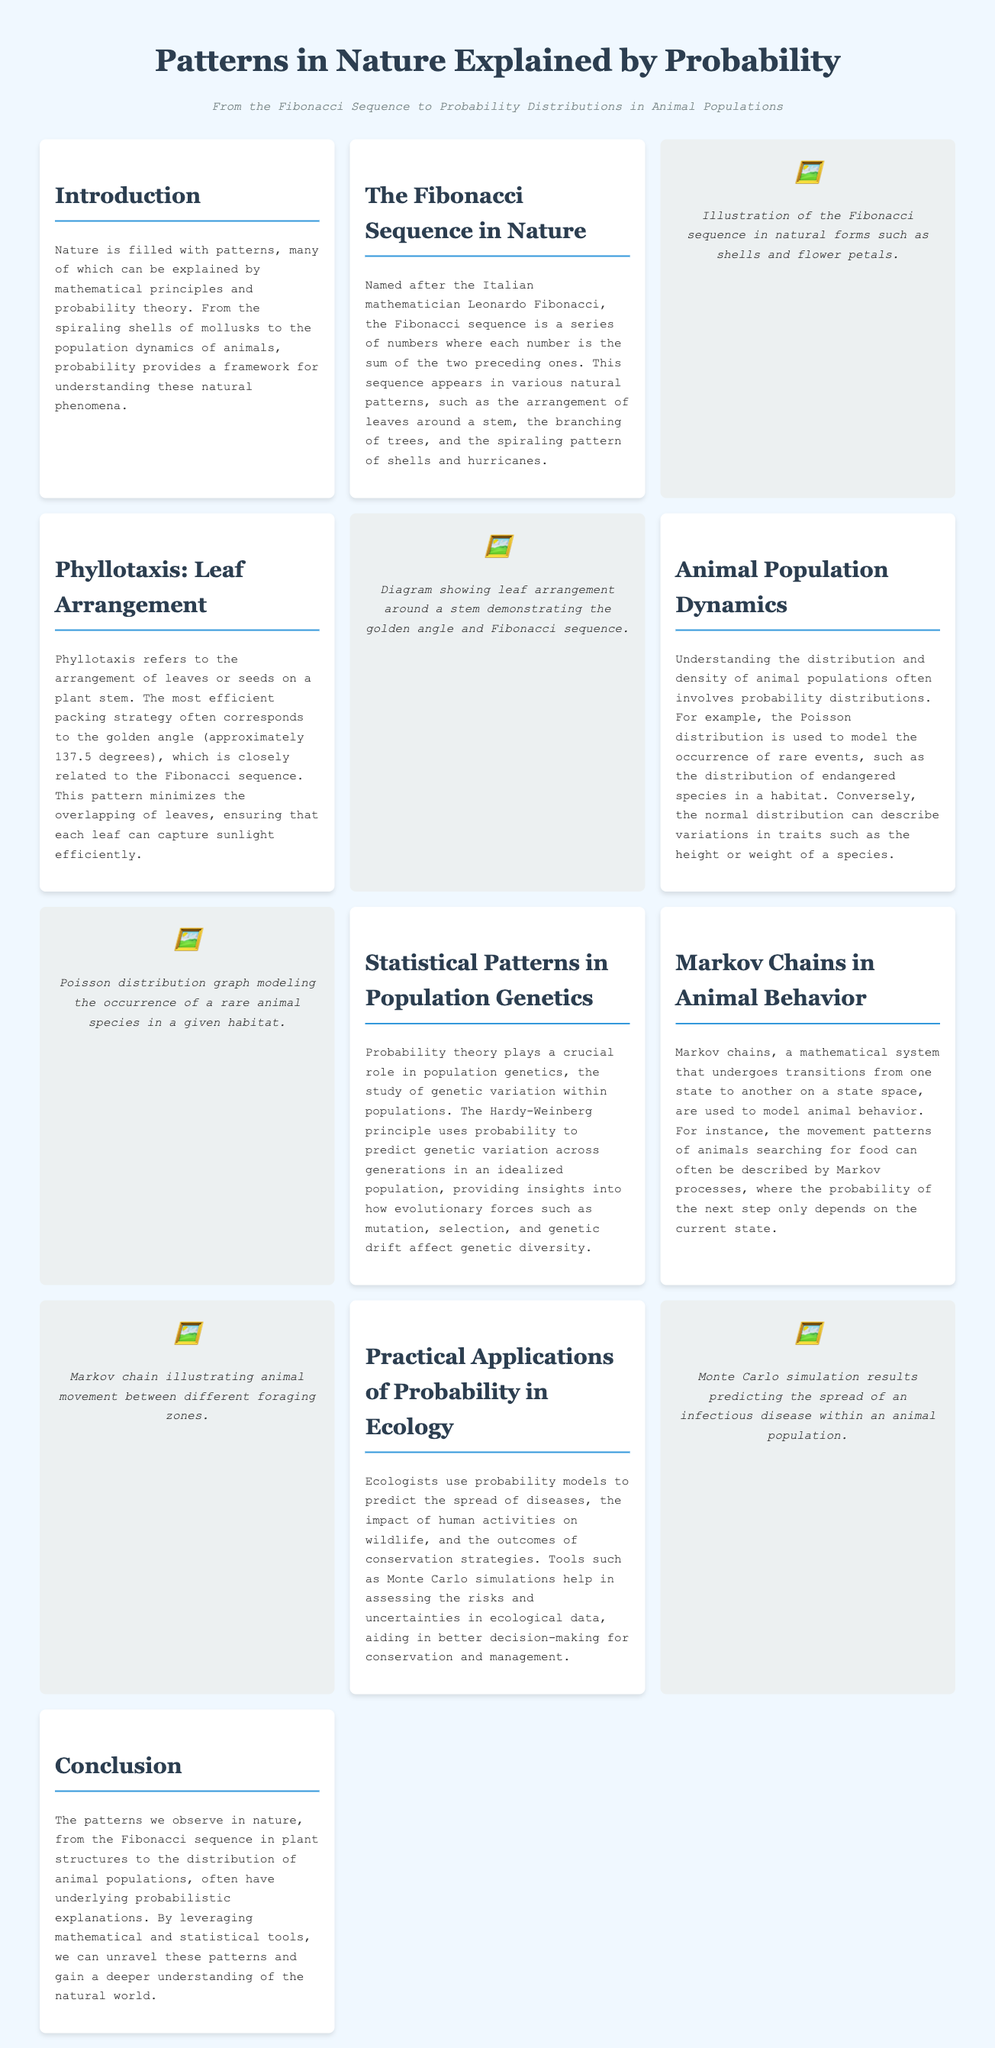What is the Fibonacci sequence? The Fibonacci sequence is a series of numbers where each number is the sum of the two preceding ones.
Answer: series of numbers What is phyllotaxis? Phyllotaxis refers to the arrangement of leaves or seeds on a plant stem.
Answer: arrangement of leaves What is the golden angle? The golden angle is approximately 137.5 degrees.
Answer: 137.5 degrees Which distribution is used to model rare events? The Poisson distribution is used to model the occurrence of rare events.
Answer: Poisson distribution What principle predicts genetic variation across generations? The Hardy-Weinberg principle uses probability to predict genetic variation across generations.
Answer: Hardy-Weinberg principle How are Markov chains used in animal behavior? Markov chains are used to model animal behavior and movement patterns.
Answer: model animal behavior What simulation tool do ecologists use for risk assessment? Ecologists use Monte Carlo simulations to assess risks and uncertainties.
Answer: Monte Carlo simulations What spiraling patterns are mentioned in relation to the Fibonacci sequence? Spiraling patterns include the spiraling pattern of shells and hurricanes.
Answer: shells and hurricanes What mathematical concept is often related to animal population dynamics? Probability distributions are related to understanding animal population dynamics.
Answer: Probability distributions 